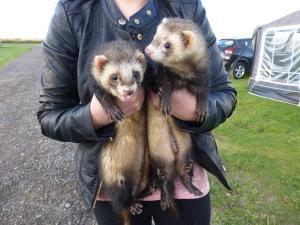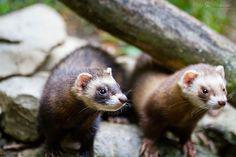The first image is the image on the left, the second image is the image on the right. Assess this claim about the two images: "An image contains a human holding two ferrets.". Correct or not? Answer yes or no. Yes. 